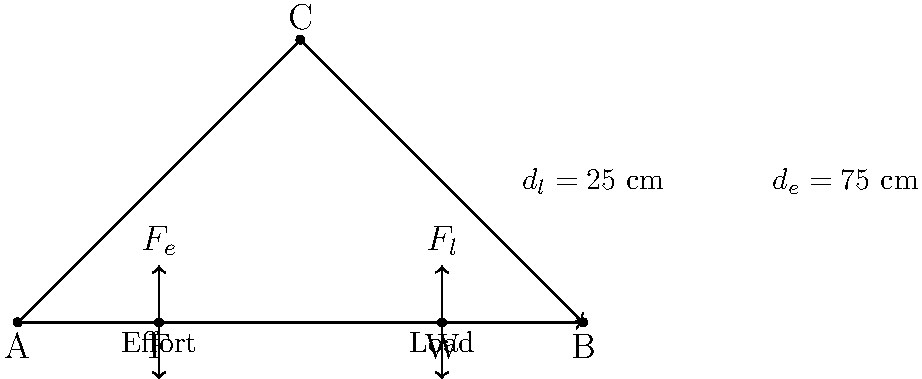A single mother is trying to fix her kitchen cabinet door using a simple lever system. The lever arm is 100 cm long, with the fulcrum (pivot point) located 25 cm from the load end. If she applies an effort of 20 N to lift a 60 N load, what is the mechanical advantage of this system? To solve this problem, we'll follow these steps:

1. Understand the concept of mechanical advantage (MA):
   MA is the ratio of the output force (load) to the input force (effort).

2. Recall the law of the lever:
   $F_e \cdot d_e = F_l \cdot d_l$
   Where $F_e$ is the effort force, $d_e$ is the effort distance,
   $F_l$ is the load force, and $d_l$ is the load distance.

3. Identify the given information:
   - Total lever length = 100 cm
   - Distance from fulcrum to load ($d_l$) = 25 cm
   - Distance from fulcrum to effort ($d_e$) = 100 cm - 25 cm = 75 cm
   - Effort force ($F_e$) = 20 N
   - Load force ($F_l$) = 60 N

4. Calculate the mechanical advantage using the formula:
   $MA = \frac{F_l}{F_e} = \frac{60 \text{ N}}{20 \text{ N}} = 3$

5. Verify the result using the law of the lever:
   $F_e \cdot d_e = F_l \cdot d_l$
   $20 \text{ N} \cdot 75 \text{ cm} = 60 \text{ N} \cdot 25 \text{ cm}$
   $1500 \text{ N}\cdot\text{cm} = 1500 \text{ N}\cdot\text{cm}$

The mechanical advantage of 3 means that the lever system allows the mother to lift a load that is 3 times heavier than the force she applies, making it easier for her to fix the cabinet door.
Answer: 3 